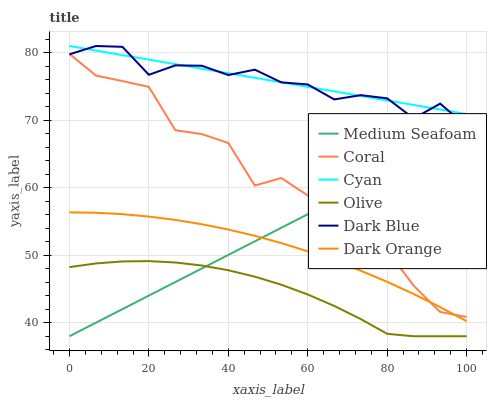Does Coral have the minimum area under the curve?
Answer yes or no. No. Does Coral have the maximum area under the curve?
Answer yes or no. No. Is Dark Blue the smoothest?
Answer yes or no. No. Is Dark Blue the roughest?
Answer yes or no. No. Does Coral have the lowest value?
Answer yes or no. No. Does Coral have the highest value?
Answer yes or no. No. Is Olive less than Cyan?
Answer yes or no. Yes. Is Dark Blue greater than Dark Orange?
Answer yes or no. Yes. Does Olive intersect Cyan?
Answer yes or no. No. 